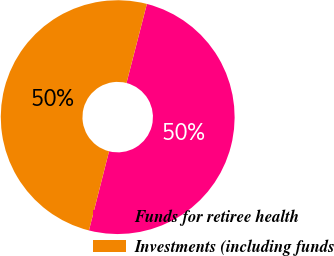Convert chart to OTSL. <chart><loc_0><loc_0><loc_500><loc_500><pie_chart><fcel>Funds for retiree health<fcel>Investments (including funds<nl><fcel>49.94%<fcel>50.06%<nl></chart> 